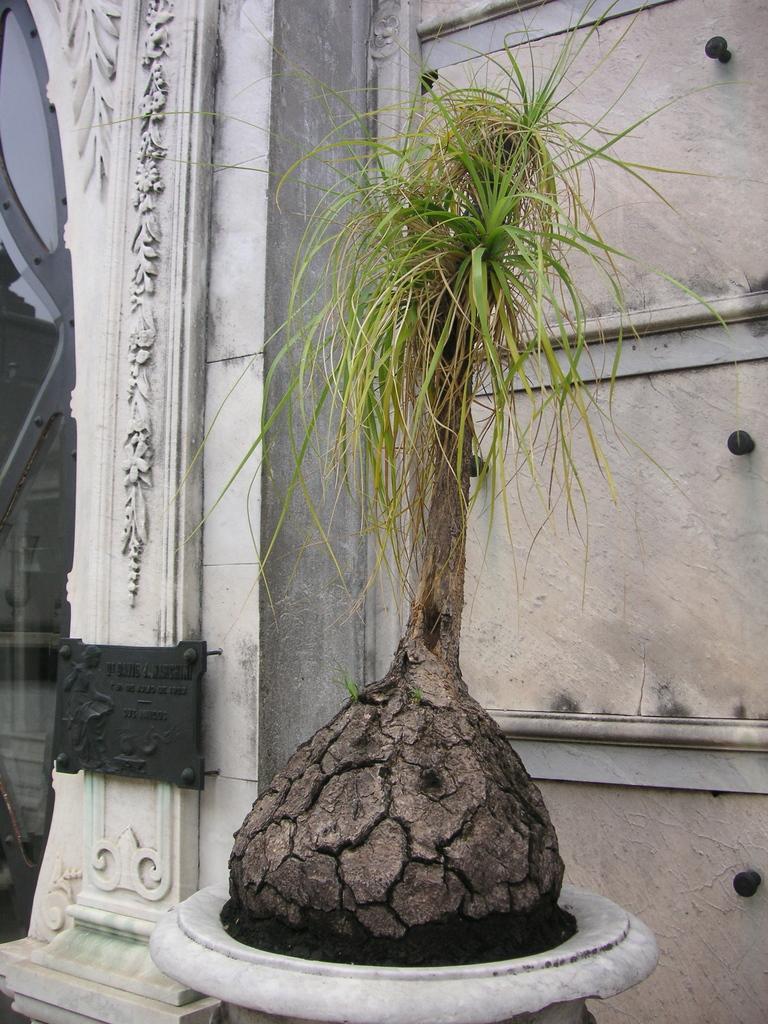How would you summarize this image in a sentence or two? In this image there is a pot plant, wall, black board and an object. 